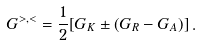<formula> <loc_0><loc_0><loc_500><loc_500>G ^ { > , < } = \frac { 1 } { 2 } [ G _ { K } \pm ( G _ { R } - G _ { A } ) ] \, .</formula> 